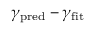Convert formula to latex. <formula><loc_0><loc_0><loc_500><loc_500>\gamma _ { p r e d } - \gamma _ { f i t }</formula> 